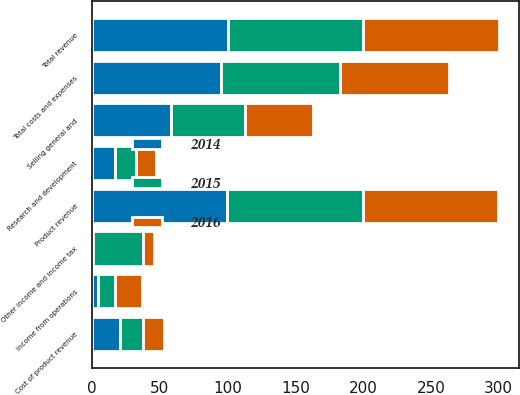Convert chart to OTSL. <chart><loc_0><loc_0><loc_500><loc_500><stacked_bar_chart><ecel><fcel>Product revenue<fcel>Total revenue<fcel>Cost of product revenue<fcel>Research and development<fcel>Selling general and<fcel>Total costs and expenses<fcel>Income from operations<fcel>Other income and income tax<nl><fcel>2016<fcel>100<fcel>100<fcel>15.3<fcel>15.1<fcel>49.8<fcel>80.2<fcel>19.8<fcel>8.2<nl><fcel>2015<fcel>99.8<fcel>100<fcel>17.3<fcel>15.6<fcel>54.6<fcel>87.5<fcel>12.5<fcel>36.9<nl><fcel>2014<fcel>99.8<fcel>100<fcel>20.3<fcel>16.7<fcel>58.4<fcel>95.4<fcel>4.6<fcel>0.6<nl></chart> 